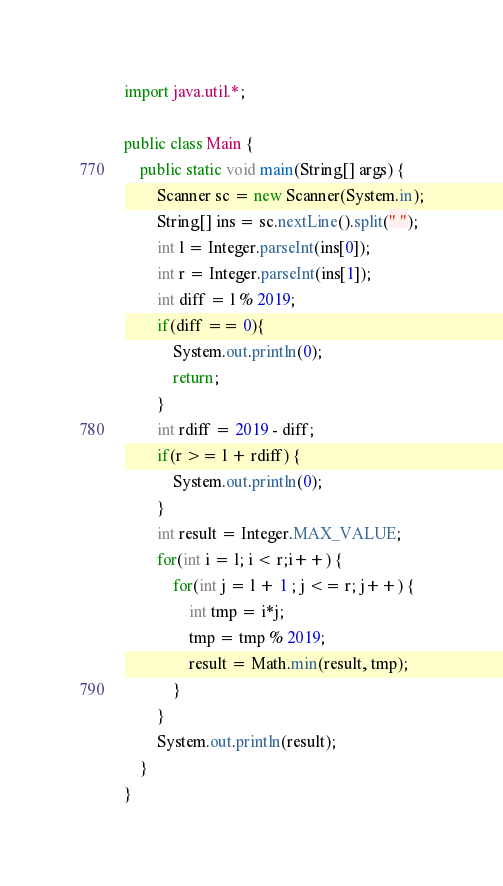Convert code to text. <code><loc_0><loc_0><loc_500><loc_500><_Java_>import java.util.*;

public class Main {
    public static void main(String[] args) {
        Scanner sc = new Scanner(System.in);
        String[] ins = sc.nextLine().split(" ");
        int l = Integer.parseInt(ins[0]);
        int r = Integer.parseInt(ins[1]);
        int diff = l % 2019;
        if(diff == 0){
            System.out.println(0);
            return;
        }
        int rdiff = 2019 - diff;
        if(r >= l + rdiff) {
            System.out.println(0);
        }
        int result = Integer.MAX_VALUE;
        for(int i = l; i < r;i++) {
            for(int j = l + 1 ; j <= r; j++) {
                int tmp = i*j;
                tmp = tmp % 2019;
                result = Math.min(result, tmp);
            }
        }
        System.out.println(result);
    }
}</code> 